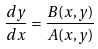<formula> <loc_0><loc_0><loc_500><loc_500>\frac { d y } { d x } = \frac { B ( x , y ) } { A ( x , y ) }</formula> 